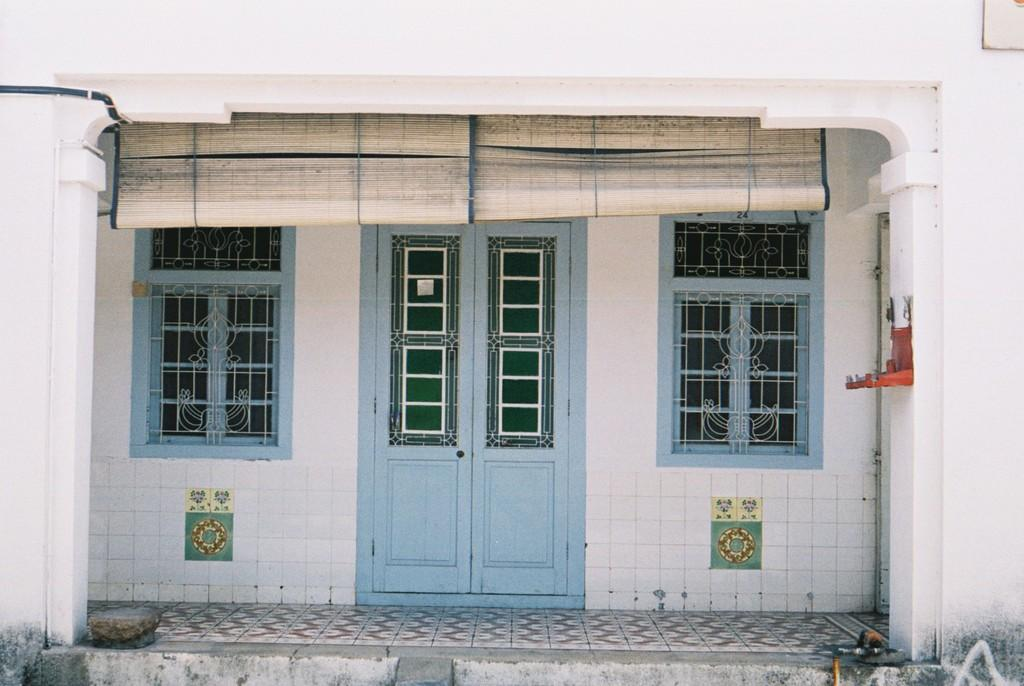What type of openings can be seen in the image? There are doors and windows in the image. What is covering part of the image? There is a sheet in the image. What can be found on the walls in the image? There are objects in the image. What is the background of the image made of? There is a wall in the image. What is at the bottom of the image? There is a floor at the bottom of the image. What type of beast can be seen roaming around in the image? There is no beast present in the image. Is there any coal visible in the image? There is no coal present in the image. 